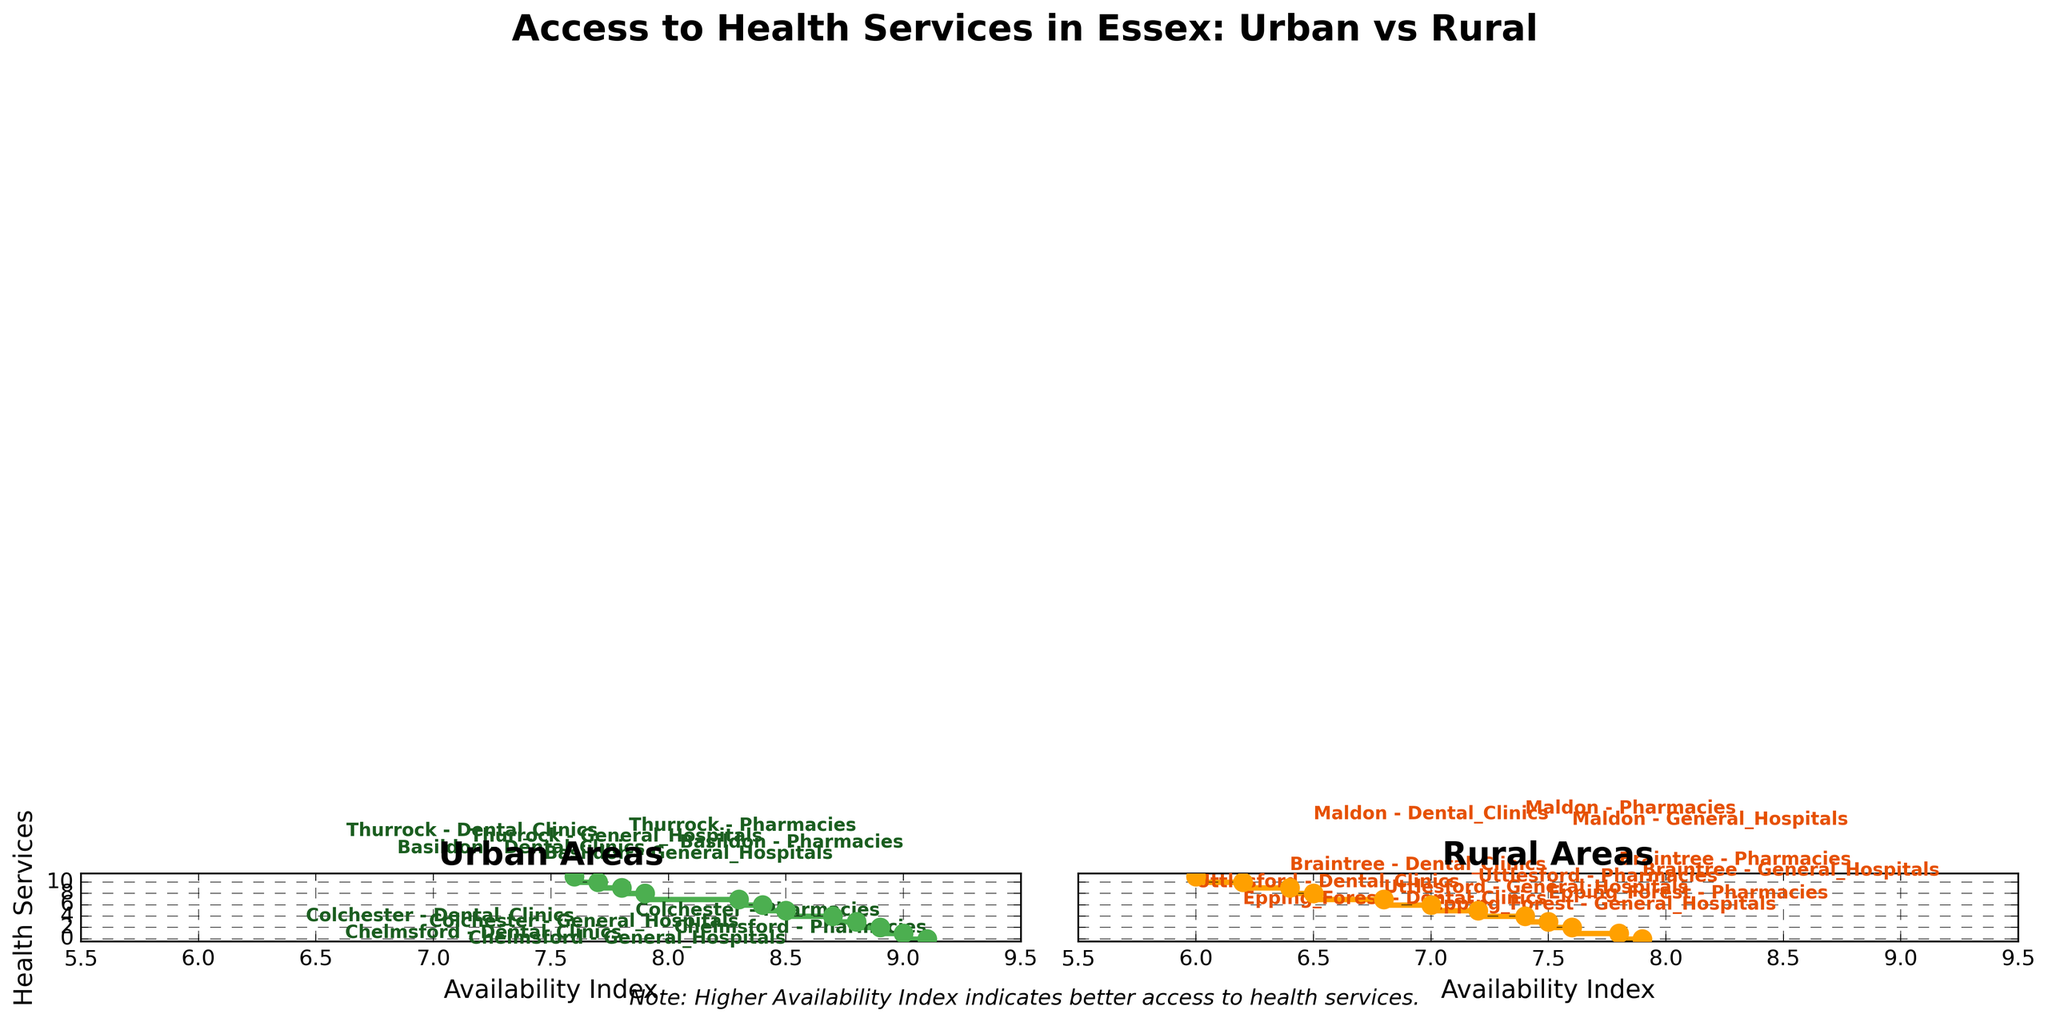What is the title of the figure? The title is located at the top of the figure and usually gives an overview of what the figure is about.
Answer: Access to Health Services in Essex: Urban vs Rural What are the colors used to represent urban and rural areas? The Urban and Rural areas are represented by different colors in the steps and scatter points. For Urban areas, a green color is used, while for Rural areas, an orange color is used.
Answer: Green (Urban) and Orange (Rural) Which health service has the highest availability index in urban areas? By examining the left plot and looking at the highest point on the Availability Index axis, we see that the highest index in Urban areas is 9.1 by Chelmsford for Pharmacies.
Answer: Pharmacies in Chelmsford How many areas are represented in the rural section? By inspecting the right-hand plot and counting the number of data points (steps or scatter points), we find that there are 10 data points, corresponding to services across different areas.
Answer: 10 Which health service in rural areas has the lowest availability index? In the right plot, the lowest value on the Availability Index axis is 6.0. By following the line, we see it corresponds to Dental Clinics in Uttlesford.
Answer: Dental Clinics in Uttlesford What is the average availability index of general hospitals in urban areas? By identifying the Availability Index values for General Hospitals in urban areas (Chelmsford 8.5, Colchester 8.3, Basildon 8.7, and Thurrock 8.4), and calculating their average: (8.5 + 8.3 + 8.7 + 8.4) / 4 = 8.475.
Answer: 8.475 Compare the availability index of pharmacies between urban and rural areas. Which area has the highest and which has the lowest availability index? From urban areas, the highest Pharmacy index is 9.1 (Chelmsford), while from rural areas, the highest is 7.8 (Braintree). The lowest rural index for pharmacies is 7.2 (Uttlesford), while the lowest urban index is 8.8 (Thurrock). Thus, Chelmsford has the highest and Uttlesford the lowest.
Answer: Highest: Chelmsford (9.1); Lowest: Uttlesford (7.2) Are there any rural areas with an availability index of 8.5 or higher? By observing the right plot, no steps or scatter points reach or exceed an index of 8.5, indicating there are no rural areas with such high availability.
Answer: No What is the difference in availability index between dental clinics in urban and rural areas? The availability indexes for Dental Clinics in urban areas are 7.8 (Chelmsford), 7.6 (Colchester), 7.9 (Basildon), and 7.7 (Thurrock). For rural areas, they are 6.2 (Epping Forest), 6.0 (Uttlesford), 6.4 (Braintree), and 6.5 (Maldon). The average for urban is (7.8 + 7.6 + 7.9 + 7.7) / 4 = 7.75, and for rural is (6.2 + 6.0 + 6.4 + 6.5) / 4 = 6.28. The difference is 7.75 - 6.28 = 1.47.
Answer: 1.47 Which area has the best access to general hospitals based on the availability index and is it urban or rural? From examining both plots, we see the highest availability index for General Hospitals is 8.7 in Basildon, which is an urban area.
Answer: Basildon, Urban 